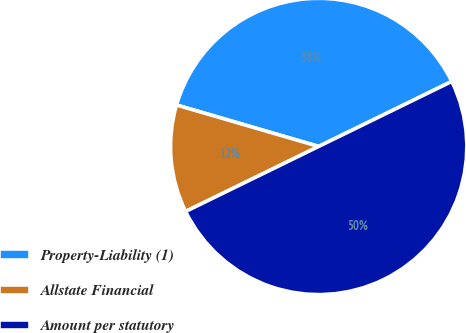<chart> <loc_0><loc_0><loc_500><loc_500><pie_chart><fcel>Property-Liability (1)<fcel>Allstate Financial<fcel>Amount per statutory<nl><fcel>38.25%<fcel>11.75%<fcel>50.0%<nl></chart> 